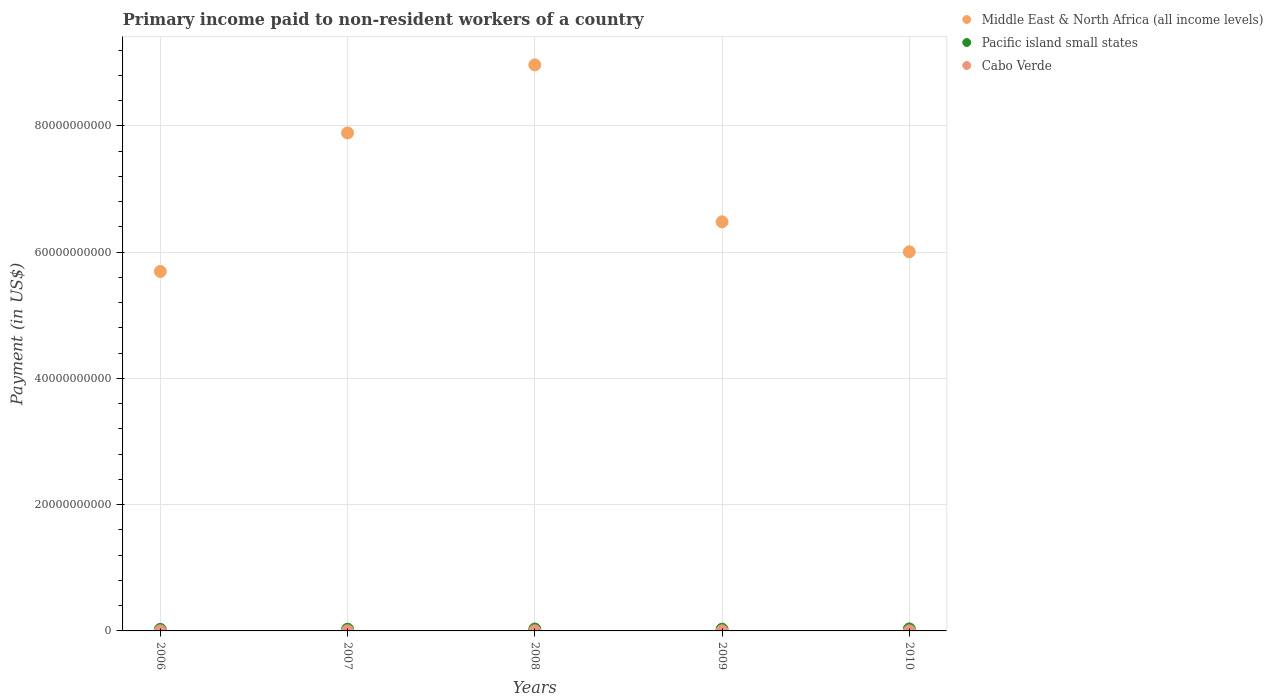What is the amount paid to workers in Cabo Verde in 2006?
Offer a terse response. 1.91e+07. Across all years, what is the maximum amount paid to workers in Pacific island small states?
Make the answer very short. 3.14e+08. Across all years, what is the minimum amount paid to workers in Cabo Verde?
Keep it short and to the point. 1.39e+07. What is the total amount paid to workers in Pacific island small states in the graph?
Ensure brevity in your answer.  1.39e+09. What is the difference between the amount paid to workers in Pacific island small states in 2008 and that in 2010?
Ensure brevity in your answer.  -1.33e+07. What is the difference between the amount paid to workers in Middle East & North Africa (all income levels) in 2009 and the amount paid to workers in Cabo Verde in 2010?
Your answer should be compact. 6.48e+1. What is the average amount paid to workers in Middle East & North Africa (all income levels) per year?
Provide a short and direct response. 7.01e+1. In the year 2009, what is the difference between the amount paid to workers in Pacific island small states and amount paid to workers in Middle East & North Africa (all income levels)?
Offer a terse response. -6.45e+1. What is the ratio of the amount paid to workers in Cabo Verde in 2009 to that in 2010?
Make the answer very short. 1.64. What is the difference between the highest and the second highest amount paid to workers in Middle East & North Africa (all income levels)?
Make the answer very short. 1.08e+1. What is the difference between the highest and the lowest amount paid to workers in Middle East & North Africa (all income levels)?
Offer a terse response. 3.27e+1. Is the sum of the amount paid to workers in Cabo Verde in 2007 and 2008 greater than the maximum amount paid to workers in Pacific island small states across all years?
Offer a very short reply. No. Is it the case that in every year, the sum of the amount paid to workers in Middle East & North Africa (all income levels) and amount paid to workers in Cabo Verde  is greater than the amount paid to workers in Pacific island small states?
Your answer should be very brief. Yes. Is the amount paid to workers in Pacific island small states strictly less than the amount paid to workers in Middle East & North Africa (all income levels) over the years?
Ensure brevity in your answer.  Yes. Are the values on the major ticks of Y-axis written in scientific E-notation?
Your answer should be compact. No. Does the graph contain any zero values?
Your answer should be very brief. No. Does the graph contain grids?
Offer a very short reply. Yes. Where does the legend appear in the graph?
Make the answer very short. Top right. How many legend labels are there?
Your answer should be very brief. 3. What is the title of the graph?
Provide a succinct answer. Primary income paid to non-resident workers of a country. Does "Nicaragua" appear as one of the legend labels in the graph?
Provide a succinct answer. No. What is the label or title of the Y-axis?
Provide a succinct answer. Payment (in US$). What is the Payment (in US$) in Middle East & North Africa (all income levels) in 2006?
Your answer should be compact. 5.69e+1. What is the Payment (in US$) of Pacific island small states in 2006?
Ensure brevity in your answer.  2.41e+08. What is the Payment (in US$) of Cabo Verde in 2006?
Provide a short and direct response. 1.91e+07. What is the Payment (in US$) in Middle East & North Africa (all income levels) in 2007?
Make the answer very short. 7.89e+1. What is the Payment (in US$) in Pacific island small states in 2007?
Your answer should be very brief. 2.68e+08. What is the Payment (in US$) of Cabo Verde in 2007?
Offer a very short reply. 2.67e+07. What is the Payment (in US$) in Middle East & North Africa (all income levels) in 2008?
Give a very brief answer. 8.97e+1. What is the Payment (in US$) of Pacific island small states in 2008?
Provide a succinct answer. 3.00e+08. What is the Payment (in US$) in Cabo Verde in 2008?
Keep it short and to the point. 2.77e+07. What is the Payment (in US$) in Middle East & North Africa (all income levels) in 2009?
Your response must be concise. 6.48e+1. What is the Payment (in US$) of Pacific island small states in 2009?
Ensure brevity in your answer.  2.72e+08. What is the Payment (in US$) in Cabo Verde in 2009?
Provide a succinct answer. 2.29e+07. What is the Payment (in US$) in Middle East & North Africa (all income levels) in 2010?
Your answer should be compact. 6.01e+1. What is the Payment (in US$) of Pacific island small states in 2010?
Provide a succinct answer. 3.14e+08. What is the Payment (in US$) in Cabo Verde in 2010?
Give a very brief answer. 1.39e+07. Across all years, what is the maximum Payment (in US$) of Middle East & North Africa (all income levels)?
Provide a succinct answer. 8.97e+1. Across all years, what is the maximum Payment (in US$) of Pacific island small states?
Offer a terse response. 3.14e+08. Across all years, what is the maximum Payment (in US$) in Cabo Verde?
Provide a short and direct response. 2.77e+07. Across all years, what is the minimum Payment (in US$) of Middle East & North Africa (all income levels)?
Offer a terse response. 5.69e+1. Across all years, what is the minimum Payment (in US$) of Pacific island small states?
Give a very brief answer. 2.41e+08. Across all years, what is the minimum Payment (in US$) of Cabo Verde?
Give a very brief answer. 1.39e+07. What is the total Payment (in US$) of Middle East & North Africa (all income levels) in the graph?
Your answer should be very brief. 3.50e+11. What is the total Payment (in US$) in Pacific island small states in the graph?
Provide a short and direct response. 1.39e+09. What is the total Payment (in US$) of Cabo Verde in the graph?
Your answer should be compact. 1.10e+08. What is the difference between the Payment (in US$) of Middle East & North Africa (all income levels) in 2006 and that in 2007?
Offer a very short reply. -2.19e+1. What is the difference between the Payment (in US$) of Pacific island small states in 2006 and that in 2007?
Your answer should be very brief. -2.71e+07. What is the difference between the Payment (in US$) in Cabo Verde in 2006 and that in 2007?
Keep it short and to the point. -7.66e+06. What is the difference between the Payment (in US$) of Middle East & North Africa (all income levels) in 2006 and that in 2008?
Provide a short and direct response. -3.27e+1. What is the difference between the Payment (in US$) in Pacific island small states in 2006 and that in 2008?
Your answer should be very brief. -5.96e+07. What is the difference between the Payment (in US$) in Cabo Verde in 2006 and that in 2008?
Give a very brief answer. -8.62e+06. What is the difference between the Payment (in US$) in Middle East & North Africa (all income levels) in 2006 and that in 2009?
Give a very brief answer. -7.86e+09. What is the difference between the Payment (in US$) in Pacific island small states in 2006 and that in 2009?
Provide a succinct answer. -3.14e+07. What is the difference between the Payment (in US$) in Cabo Verde in 2006 and that in 2009?
Your response must be concise. -3.81e+06. What is the difference between the Payment (in US$) of Middle East & North Africa (all income levels) in 2006 and that in 2010?
Your response must be concise. -3.11e+09. What is the difference between the Payment (in US$) in Pacific island small states in 2006 and that in 2010?
Your answer should be very brief. -7.29e+07. What is the difference between the Payment (in US$) in Cabo Verde in 2006 and that in 2010?
Provide a succinct answer. 5.16e+06. What is the difference between the Payment (in US$) in Middle East & North Africa (all income levels) in 2007 and that in 2008?
Offer a very short reply. -1.08e+1. What is the difference between the Payment (in US$) of Pacific island small states in 2007 and that in 2008?
Provide a succinct answer. -3.25e+07. What is the difference between the Payment (in US$) of Cabo Verde in 2007 and that in 2008?
Give a very brief answer. -9.58e+05. What is the difference between the Payment (in US$) of Middle East & North Africa (all income levels) in 2007 and that in 2009?
Give a very brief answer. 1.41e+1. What is the difference between the Payment (in US$) of Pacific island small states in 2007 and that in 2009?
Keep it short and to the point. -4.37e+06. What is the difference between the Payment (in US$) of Cabo Verde in 2007 and that in 2009?
Ensure brevity in your answer.  3.84e+06. What is the difference between the Payment (in US$) of Middle East & North Africa (all income levels) in 2007 and that in 2010?
Give a very brief answer. 1.88e+1. What is the difference between the Payment (in US$) in Pacific island small states in 2007 and that in 2010?
Provide a short and direct response. -4.58e+07. What is the difference between the Payment (in US$) of Cabo Verde in 2007 and that in 2010?
Your answer should be compact. 1.28e+07. What is the difference between the Payment (in US$) in Middle East & North Africa (all income levels) in 2008 and that in 2009?
Provide a succinct answer. 2.49e+1. What is the difference between the Payment (in US$) of Pacific island small states in 2008 and that in 2009?
Give a very brief answer. 2.82e+07. What is the difference between the Payment (in US$) of Cabo Verde in 2008 and that in 2009?
Give a very brief answer. 4.80e+06. What is the difference between the Payment (in US$) of Middle East & North Africa (all income levels) in 2008 and that in 2010?
Make the answer very short. 2.96e+1. What is the difference between the Payment (in US$) in Pacific island small states in 2008 and that in 2010?
Your answer should be compact. -1.33e+07. What is the difference between the Payment (in US$) in Cabo Verde in 2008 and that in 2010?
Make the answer very short. 1.38e+07. What is the difference between the Payment (in US$) in Middle East & North Africa (all income levels) in 2009 and that in 2010?
Provide a succinct answer. 4.75e+09. What is the difference between the Payment (in US$) in Pacific island small states in 2009 and that in 2010?
Your answer should be compact. -4.14e+07. What is the difference between the Payment (in US$) in Cabo Verde in 2009 and that in 2010?
Your answer should be very brief. 8.97e+06. What is the difference between the Payment (in US$) in Middle East & North Africa (all income levels) in 2006 and the Payment (in US$) in Pacific island small states in 2007?
Keep it short and to the point. 5.67e+1. What is the difference between the Payment (in US$) in Middle East & North Africa (all income levels) in 2006 and the Payment (in US$) in Cabo Verde in 2007?
Your answer should be very brief. 5.69e+1. What is the difference between the Payment (in US$) of Pacific island small states in 2006 and the Payment (in US$) of Cabo Verde in 2007?
Offer a very short reply. 2.14e+08. What is the difference between the Payment (in US$) in Middle East & North Africa (all income levels) in 2006 and the Payment (in US$) in Pacific island small states in 2008?
Ensure brevity in your answer.  5.66e+1. What is the difference between the Payment (in US$) of Middle East & North Africa (all income levels) in 2006 and the Payment (in US$) of Cabo Verde in 2008?
Your answer should be compact. 5.69e+1. What is the difference between the Payment (in US$) of Pacific island small states in 2006 and the Payment (in US$) of Cabo Verde in 2008?
Give a very brief answer. 2.13e+08. What is the difference between the Payment (in US$) in Middle East & North Africa (all income levels) in 2006 and the Payment (in US$) in Pacific island small states in 2009?
Offer a terse response. 5.67e+1. What is the difference between the Payment (in US$) in Middle East & North Africa (all income levels) in 2006 and the Payment (in US$) in Cabo Verde in 2009?
Make the answer very short. 5.69e+1. What is the difference between the Payment (in US$) of Pacific island small states in 2006 and the Payment (in US$) of Cabo Verde in 2009?
Provide a short and direct response. 2.18e+08. What is the difference between the Payment (in US$) of Middle East & North Africa (all income levels) in 2006 and the Payment (in US$) of Pacific island small states in 2010?
Your response must be concise. 5.66e+1. What is the difference between the Payment (in US$) in Middle East & North Africa (all income levels) in 2006 and the Payment (in US$) in Cabo Verde in 2010?
Ensure brevity in your answer.  5.69e+1. What is the difference between the Payment (in US$) in Pacific island small states in 2006 and the Payment (in US$) in Cabo Verde in 2010?
Your answer should be very brief. 2.27e+08. What is the difference between the Payment (in US$) of Middle East & North Africa (all income levels) in 2007 and the Payment (in US$) of Pacific island small states in 2008?
Give a very brief answer. 7.86e+1. What is the difference between the Payment (in US$) in Middle East & North Africa (all income levels) in 2007 and the Payment (in US$) in Cabo Verde in 2008?
Your answer should be compact. 7.89e+1. What is the difference between the Payment (in US$) of Pacific island small states in 2007 and the Payment (in US$) of Cabo Verde in 2008?
Give a very brief answer. 2.40e+08. What is the difference between the Payment (in US$) of Middle East & North Africa (all income levels) in 2007 and the Payment (in US$) of Pacific island small states in 2009?
Keep it short and to the point. 7.86e+1. What is the difference between the Payment (in US$) of Middle East & North Africa (all income levels) in 2007 and the Payment (in US$) of Cabo Verde in 2009?
Give a very brief answer. 7.89e+1. What is the difference between the Payment (in US$) of Pacific island small states in 2007 and the Payment (in US$) of Cabo Verde in 2009?
Make the answer very short. 2.45e+08. What is the difference between the Payment (in US$) of Middle East & North Africa (all income levels) in 2007 and the Payment (in US$) of Pacific island small states in 2010?
Offer a very short reply. 7.86e+1. What is the difference between the Payment (in US$) of Middle East & North Africa (all income levels) in 2007 and the Payment (in US$) of Cabo Verde in 2010?
Offer a terse response. 7.89e+1. What is the difference between the Payment (in US$) of Pacific island small states in 2007 and the Payment (in US$) of Cabo Verde in 2010?
Ensure brevity in your answer.  2.54e+08. What is the difference between the Payment (in US$) of Middle East & North Africa (all income levels) in 2008 and the Payment (in US$) of Pacific island small states in 2009?
Ensure brevity in your answer.  8.94e+1. What is the difference between the Payment (in US$) of Middle East & North Africa (all income levels) in 2008 and the Payment (in US$) of Cabo Verde in 2009?
Your answer should be very brief. 8.96e+1. What is the difference between the Payment (in US$) of Pacific island small states in 2008 and the Payment (in US$) of Cabo Verde in 2009?
Keep it short and to the point. 2.77e+08. What is the difference between the Payment (in US$) in Middle East & North Africa (all income levels) in 2008 and the Payment (in US$) in Pacific island small states in 2010?
Ensure brevity in your answer.  8.94e+1. What is the difference between the Payment (in US$) in Middle East & North Africa (all income levels) in 2008 and the Payment (in US$) in Cabo Verde in 2010?
Your response must be concise. 8.97e+1. What is the difference between the Payment (in US$) in Pacific island small states in 2008 and the Payment (in US$) in Cabo Verde in 2010?
Your response must be concise. 2.86e+08. What is the difference between the Payment (in US$) in Middle East & North Africa (all income levels) in 2009 and the Payment (in US$) in Pacific island small states in 2010?
Provide a short and direct response. 6.45e+1. What is the difference between the Payment (in US$) in Middle East & North Africa (all income levels) in 2009 and the Payment (in US$) in Cabo Verde in 2010?
Offer a very short reply. 6.48e+1. What is the difference between the Payment (in US$) in Pacific island small states in 2009 and the Payment (in US$) in Cabo Verde in 2010?
Offer a terse response. 2.58e+08. What is the average Payment (in US$) in Middle East & North Africa (all income levels) per year?
Make the answer very short. 7.01e+1. What is the average Payment (in US$) in Pacific island small states per year?
Ensure brevity in your answer.  2.79e+08. What is the average Payment (in US$) of Cabo Verde per year?
Your answer should be compact. 2.21e+07. In the year 2006, what is the difference between the Payment (in US$) in Middle East & North Africa (all income levels) and Payment (in US$) in Pacific island small states?
Offer a terse response. 5.67e+1. In the year 2006, what is the difference between the Payment (in US$) of Middle East & North Africa (all income levels) and Payment (in US$) of Cabo Verde?
Your response must be concise. 5.69e+1. In the year 2006, what is the difference between the Payment (in US$) of Pacific island small states and Payment (in US$) of Cabo Verde?
Give a very brief answer. 2.22e+08. In the year 2007, what is the difference between the Payment (in US$) of Middle East & North Africa (all income levels) and Payment (in US$) of Pacific island small states?
Give a very brief answer. 7.86e+1. In the year 2007, what is the difference between the Payment (in US$) of Middle East & North Africa (all income levels) and Payment (in US$) of Cabo Verde?
Make the answer very short. 7.89e+1. In the year 2007, what is the difference between the Payment (in US$) of Pacific island small states and Payment (in US$) of Cabo Verde?
Give a very brief answer. 2.41e+08. In the year 2008, what is the difference between the Payment (in US$) of Middle East & North Africa (all income levels) and Payment (in US$) of Pacific island small states?
Your response must be concise. 8.94e+1. In the year 2008, what is the difference between the Payment (in US$) in Middle East & North Africa (all income levels) and Payment (in US$) in Cabo Verde?
Offer a very short reply. 8.96e+1. In the year 2008, what is the difference between the Payment (in US$) of Pacific island small states and Payment (in US$) of Cabo Verde?
Offer a terse response. 2.73e+08. In the year 2009, what is the difference between the Payment (in US$) in Middle East & North Africa (all income levels) and Payment (in US$) in Pacific island small states?
Offer a terse response. 6.45e+1. In the year 2009, what is the difference between the Payment (in US$) of Middle East & North Africa (all income levels) and Payment (in US$) of Cabo Verde?
Ensure brevity in your answer.  6.48e+1. In the year 2009, what is the difference between the Payment (in US$) of Pacific island small states and Payment (in US$) of Cabo Verde?
Offer a very short reply. 2.49e+08. In the year 2010, what is the difference between the Payment (in US$) of Middle East & North Africa (all income levels) and Payment (in US$) of Pacific island small states?
Your answer should be compact. 5.97e+1. In the year 2010, what is the difference between the Payment (in US$) in Middle East & North Africa (all income levels) and Payment (in US$) in Cabo Verde?
Provide a succinct answer. 6.00e+1. In the year 2010, what is the difference between the Payment (in US$) of Pacific island small states and Payment (in US$) of Cabo Verde?
Keep it short and to the point. 3.00e+08. What is the ratio of the Payment (in US$) in Middle East & North Africa (all income levels) in 2006 to that in 2007?
Provide a short and direct response. 0.72. What is the ratio of the Payment (in US$) of Pacific island small states in 2006 to that in 2007?
Provide a succinct answer. 0.9. What is the ratio of the Payment (in US$) in Cabo Verde in 2006 to that in 2007?
Your answer should be very brief. 0.71. What is the ratio of the Payment (in US$) in Middle East & North Africa (all income levels) in 2006 to that in 2008?
Make the answer very short. 0.64. What is the ratio of the Payment (in US$) in Pacific island small states in 2006 to that in 2008?
Make the answer very short. 0.8. What is the ratio of the Payment (in US$) in Cabo Verde in 2006 to that in 2008?
Your response must be concise. 0.69. What is the ratio of the Payment (in US$) of Middle East & North Africa (all income levels) in 2006 to that in 2009?
Offer a very short reply. 0.88. What is the ratio of the Payment (in US$) of Pacific island small states in 2006 to that in 2009?
Provide a short and direct response. 0.88. What is the ratio of the Payment (in US$) in Cabo Verde in 2006 to that in 2009?
Make the answer very short. 0.83. What is the ratio of the Payment (in US$) of Middle East & North Africa (all income levels) in 2006 to that in 2010?
Your answer should be very brief. 0.95. What is the ratio of the Payment (in US$) in Pacific island small states in 2006 to that in 2010?
Keep it short and to the point. 0.77. What is the ratio of the Payment (in US$) in Cabo Verde in 2006 to that in 2010?
Keep it short and to the point. 1.37. What is the ratio of the Payment (in US$) of Middle East & North Africa (all income levels) in 2007 to that in 2008?
Give a very brief answer. 0.88. What is the ratio of the Payment (in US$) in Pacific island small states in 2007 to that in 2008?
Ensure brevity in your answer.  0.89. What is the ratio of the Payment (in US$) in Cabo Verde in 2007 to that in 2008?
Your answer should be compact. 0.97. What is the ratio of the Payment (in US$) of Middle East & North Africa (all income levels) in 2007 to that in 2009?
Make the answer very short. 1.22. What is the ratio of the Payment (in US$) of Pacific island small states in 2007 to that in 2009?
Ensure brevity in your answer.  0.98. What is the ratio of the Payment (in US$) in Cabo Verde in 2007 to that in 2009?
Your answer should be very brief. 1.17. What is the ratio of the Payment (in US$) of Middle East & North Africa (all income levels) in 2007 to that in 2010?
Offer a very short reply. 1.31. What is the ratio of the Payment (in US$) in Pacific island small states in 2007 to that in 2010?
Provide a succinct answer. 0.85. What is the ratio of the Payment (in US$) of Cabo Verde in 2007 to that in 2010?
Provide a short and direct response. 1.92. What is the ratio of the Payment (in US$) of Middle East & North Africa (all income levels) in 2008 to that in 2009?
Keep it short and to the point. 1.38. What is the ratio of the Payment (in US$) of Pacific island small states in 2008 to that in 2009?
Your response must be concise. 1.1. What is the ratio of the Payment (in US$) in Cabo Verde in 2008 to that in 2009?
Ensure brevity in your answer.  1.21. What is the ratio of the Payment (in US$) in Middle East & North Africa (all income levels) in 2008 to that in 2010?
Provide a succinct answer. 1.49. What is the ratio of the Payment (in US$) in Pacific island small states in 2008 to that in 2010?
Your response must be concise. 0.96. What is the ratio of the Payment (in US$) in Cabo Verde in 2008 to that in 2010?
Provide a succinct answer. 1.99. What is the ratio of the Payment (in US$) in Middle East & North Africa (all income levels) in 2009 to that in 2010?
Make the answer very short. 1.08. What is the ratio of the Payment (in US$) in Pacific island small states in 2009 to that in 2010?
Make the answer very short. 0.87. What is the ratio of the Payment (in US$) in Cabo Verde in 2009 to that in 2010?
Provide a succinct answer. 1.64. What is the difference between the highest and the second highest Payment (in US$) in Middle East & North Africa (all income levels)?
Give a very brief answer. 1.08e+1. What is the difference between the highest and the second highest Payment (in US$) of Pacific island small states?
Provide a succinct answer. 1.33e+07. What is the difference between the highest and the second highest Payment (in US$) of Cabo Verde?
Give a very brief answer. 9.58e+05. What is the difference between the highest and the lowest Payment (in US$) of Middle East & North Africa (all income levels)?
Your answer should be compact. 3.27e+1. What is the difference between the highest and the lowest Payment (in US$) of Pacific island small states?
Your response must be concise. 7.29e+07. What is the difference between the highest and the lowest Payment (in US$) in Cabo Verde?
Your answer should be compact. 1.38e+07. 